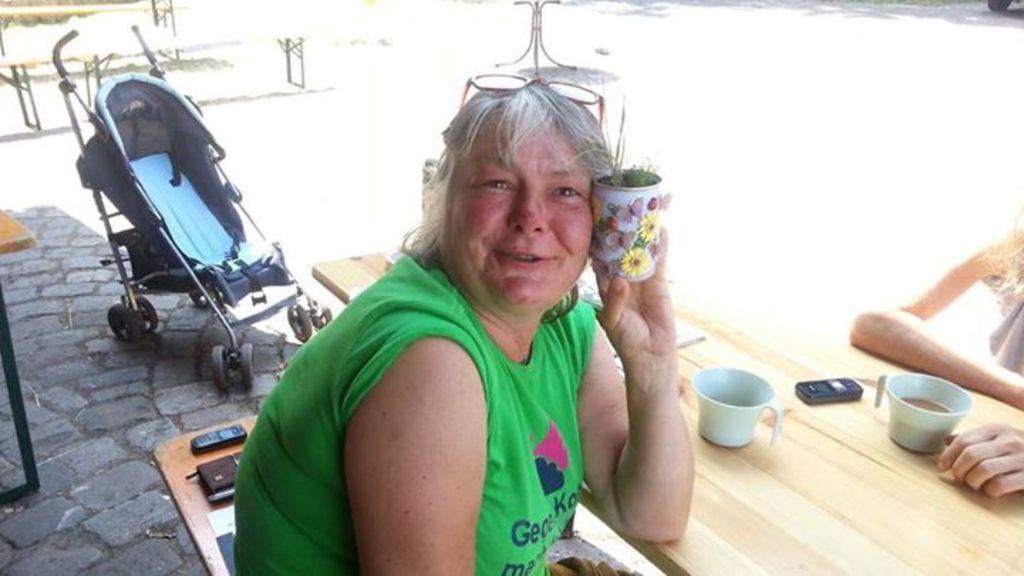Can you describe this image briefly? There is a woman sitting at the center and she is holding plant in her hand. It is a wooden table. It is a cup. This is a mobile phone which is placed on the wooden table and there is a baby carrier at the left corner. 